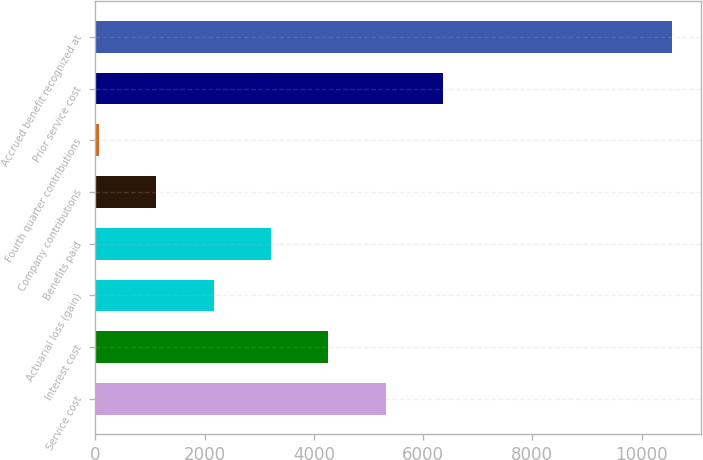<chart> <loc_0><loc_0><loc_500><loc_500><bar_chart><fcel>Service cost<fcel>Interest cost<fcel>Actuarial loss (gain)<fcel>Benefits paid<fcel>Company contributions<fcel>Fourth quarter contributions<fcel>Prior service cost<fcel>Accrued benefit recognized at<nl><fcel>5314<fcel>4264.4<fcel>2165.2<fcel>3214.8<fcel>1115.6<fcel>66<fcel>6363.6<fcel>10562<nl></chart> 